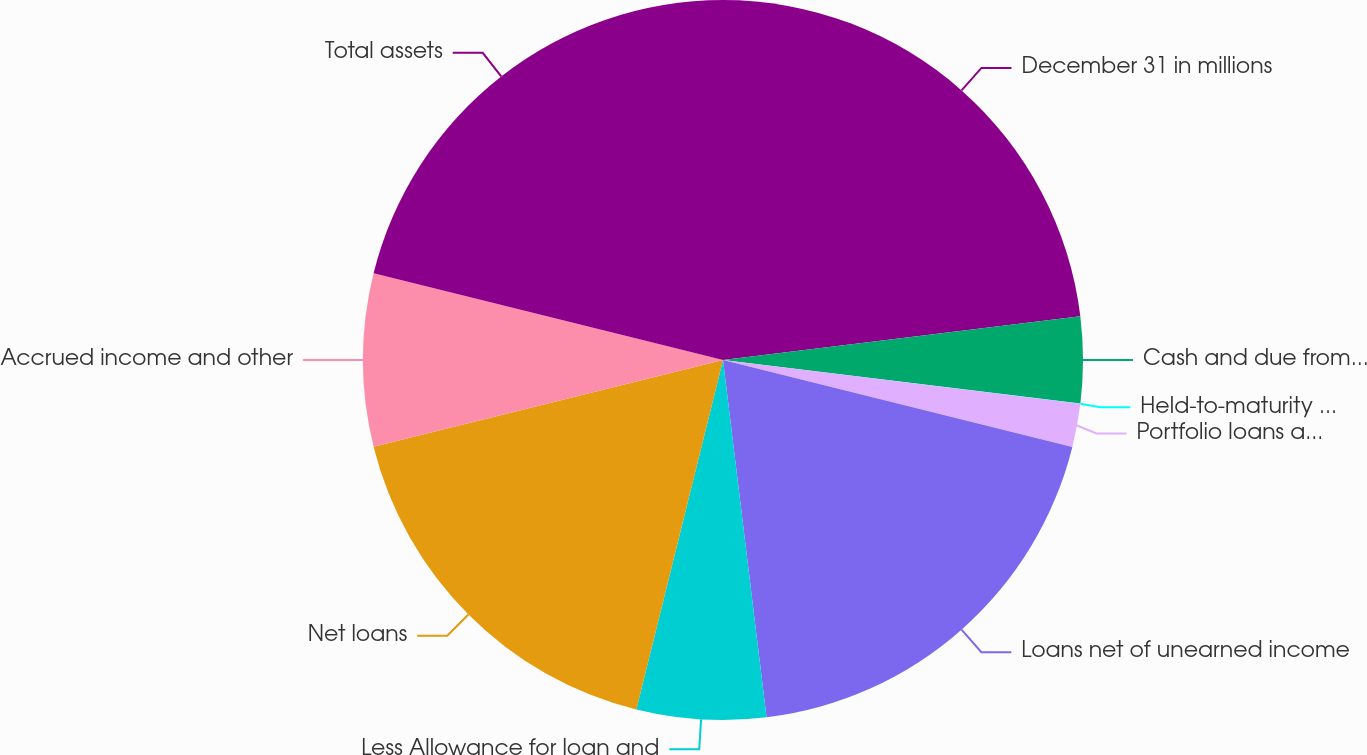<chart> <loc_0><loc_0><loc_500><loc_500><pie_chart><fcel>December 31 in millions<fcel>Cash and due from banks<fcel>Held-to-maturity securities<fcel>Portfolio loans at fair value<fcel>Loans net of unearned income<fcel>Less Allowance for loan and<fcel>Net loans<fcel>Accrued income and other<fcel>Total assets<nl><fcel>23.06%<fcel>3.87%<fcel>0.01%<fcel>1.94%<fcel>19.19%<fcel>5.8%<fcel>17.26%<fcel>7.74%<fcel>21.13%<nl></chart> 